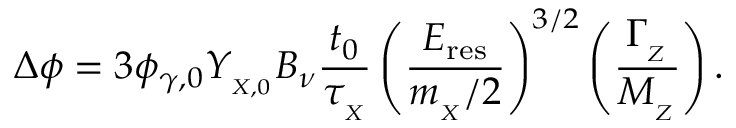<formula> <loc_0><loc_0><loc_500><loc_500>\Delta \phi = 3 \phi _ { \gamma , 0 } Y _ { _ { X , 0 } } B _ { \nu } { \frac { t _ { 0 } } { \tau _ { _ { X } } } } \left ( \frac { E _ { r e s } } { m _ { _ { X } } / 2 } \right ) ^ { 3 / 2 } \left ( \frac { \Gamma _ { _ { Z } } } { M _ { _ { Z } } } \right ) .</formula> 